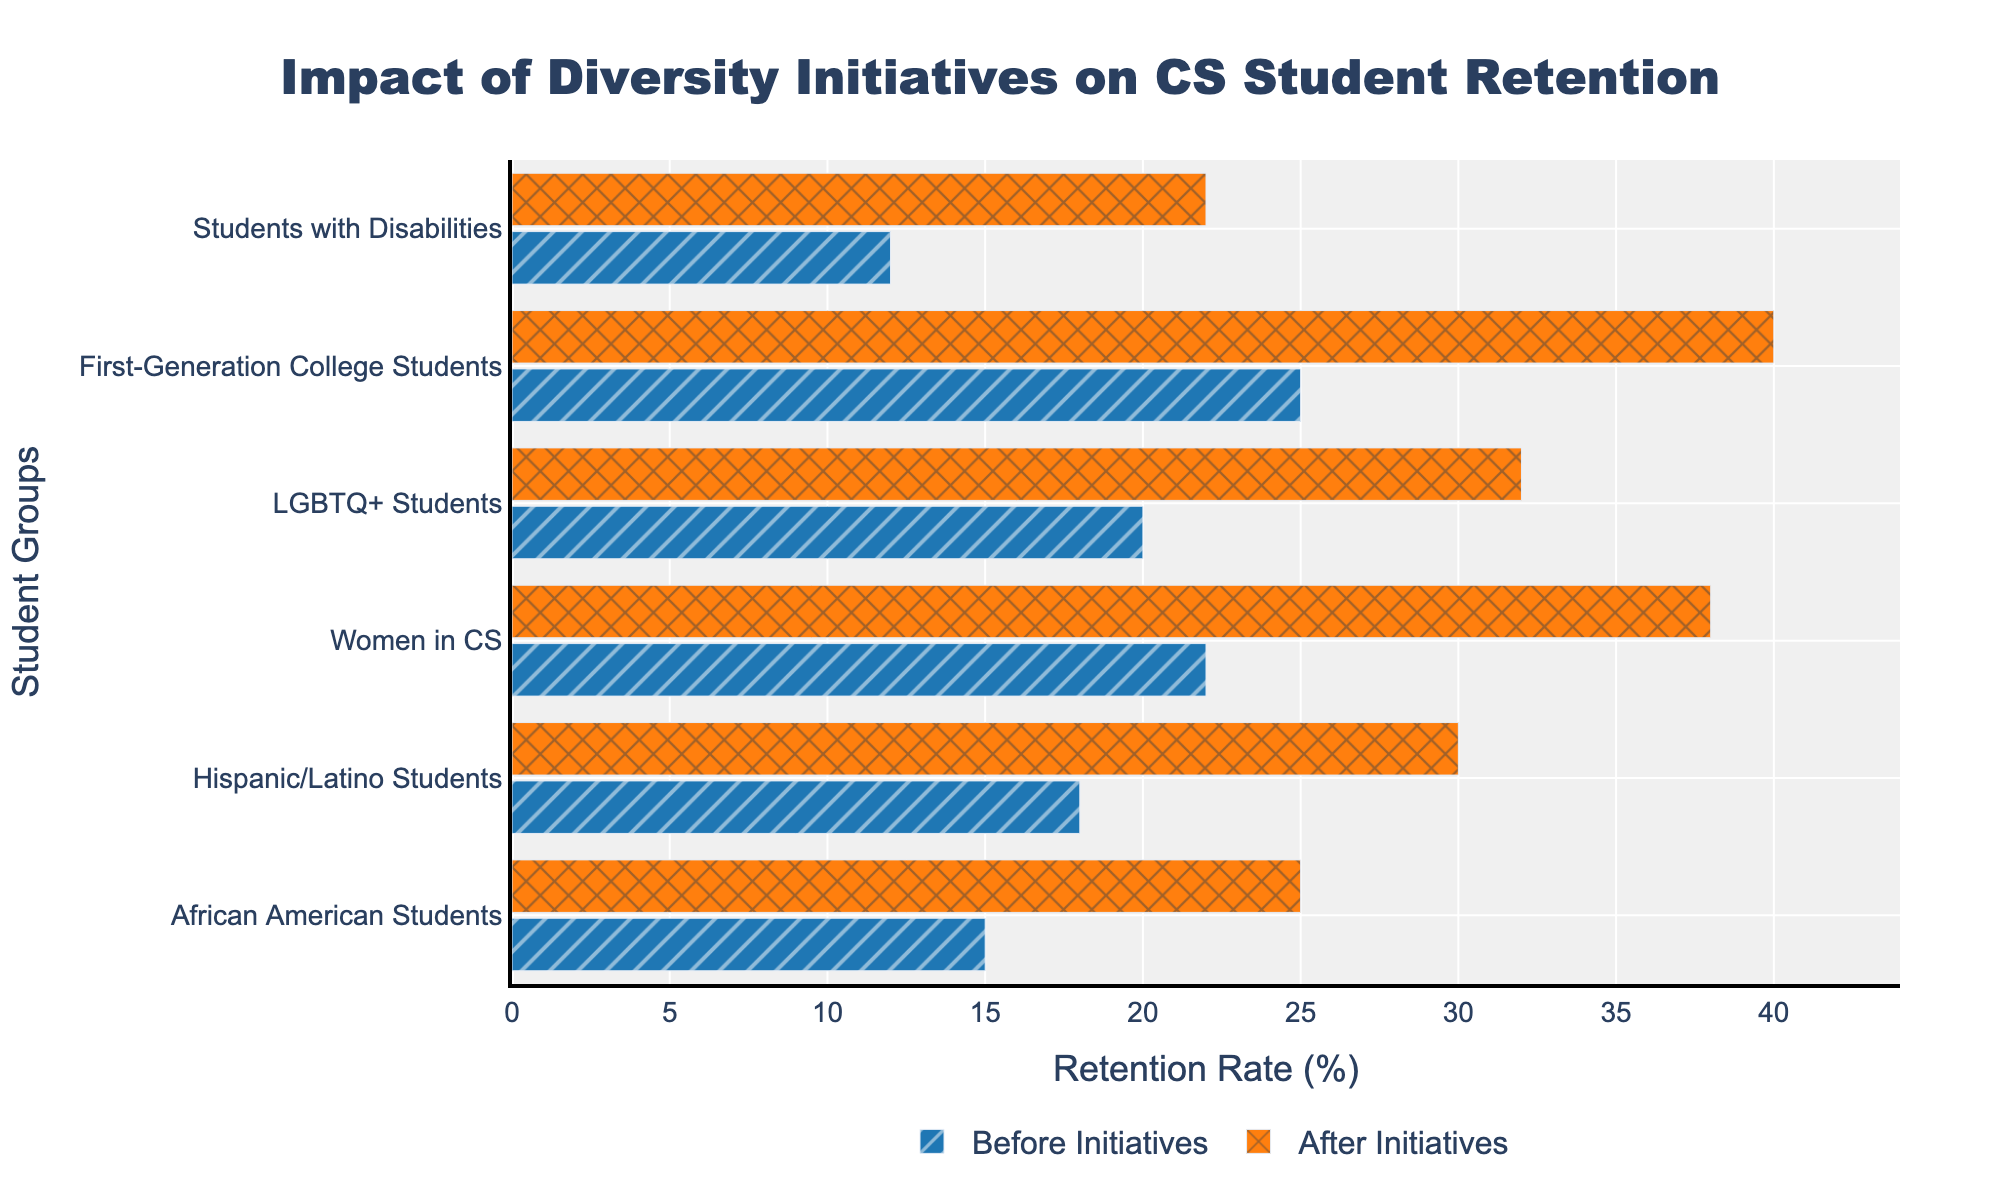What is the retention rate of Hispanic/Latino Students before and after the diversity initiatives? The graph shows retention rates for both before and after initiatives. For Hispanic/Latino Students, you can locate the bars labeled for them. By checking the length of the bars, the before rate is 18% and the after rate is 30%
Answer: Before: 18%, After: 30% What is the group with the highest retention rate after the initiatives? To find the group with the highest retention rate after the initiatives, compare the heights of the orange bars (representing after initiatives) for each group. The tallest bar represents First-Generation College Students with a retention rate of 40%
Answer: First-Generation College Students How much did the retention rate for Women in CS improve after the diversity initiatives? Subtract the retention rate before the initiatives from the retention rate after the initiatives for Women in CS. The rates are 38% (after) and 22% (before). The difference is 38% - 22% = 16%
Answer: 16% Which group saw the least improvement in retention rate after the initiatives? Calculate the improvement for each group by subtracting the 'before' retention rate from the 'after' rate. The group with the smallest difference is African American Students with an increase from 15% to 25%, resulting in an improvement of 10%
Answer: African American Students What is the average retention rate across all groups after the initiatives? Add all the retention rates after initiatives and divide by the number of groups. The rates are 25%, 30%, 38%, 32%, 40%, and 22%. The sum is 187% and there are 6 groups, so the average is 187% / 6 ≈ 31.2%
Answer: 31.2% Which two groups had equal retention rates after the diversity initiatives? By looking at the bars labeled for each group and their heights, check for equal lengths. Both African American Students and Students with Disabilities had a retention rate of 22% after the initiatives
Answer: African American Students and Students with Disabilities How does the retention rate for LGBTQ+ Students before initiatives compare to African American Students after initiatives? Locate the bars for LGBTQ+ Students before initiatives (20%) and African American Students after initiatives (25%). Compare their values to find that LGBTQ+ Students have a lower rate before initiatives
Answer: LGBTQ+ Students (20%) < African American Students (25%) What is the total improvement in retention rates across all groups? Calculate the improvement for each group and sum them up. The improvements are 10% (African American Students), 12% (Hispanic/Latino Students), 16% (Women in CS), 12% (LGBTQ+ Students), 15% (First-Generation College Students), and 10% (Students with Disabilities). The total is 10% + 12% + 16% + 12% + 15% + 10% = 75%
Answer: 75% What is the difference in retention rate change between the most and least improved groups? Find the most improved group (First-Generation College Students, 15%) and the least improved group (African American Students, 10%). The difference is 15% - 10% = 5%
Answer: 5% What is the trend observed in retention rates after the implementation of diversity initiatives? By comparing all the before and after bars across the groups, it is clear that all groups saw an increase in retention rates after the initiatives. This indicates a positive trend in retention rates after the diversity initiatives were implemented
Answer: Positive trend in retention rates 